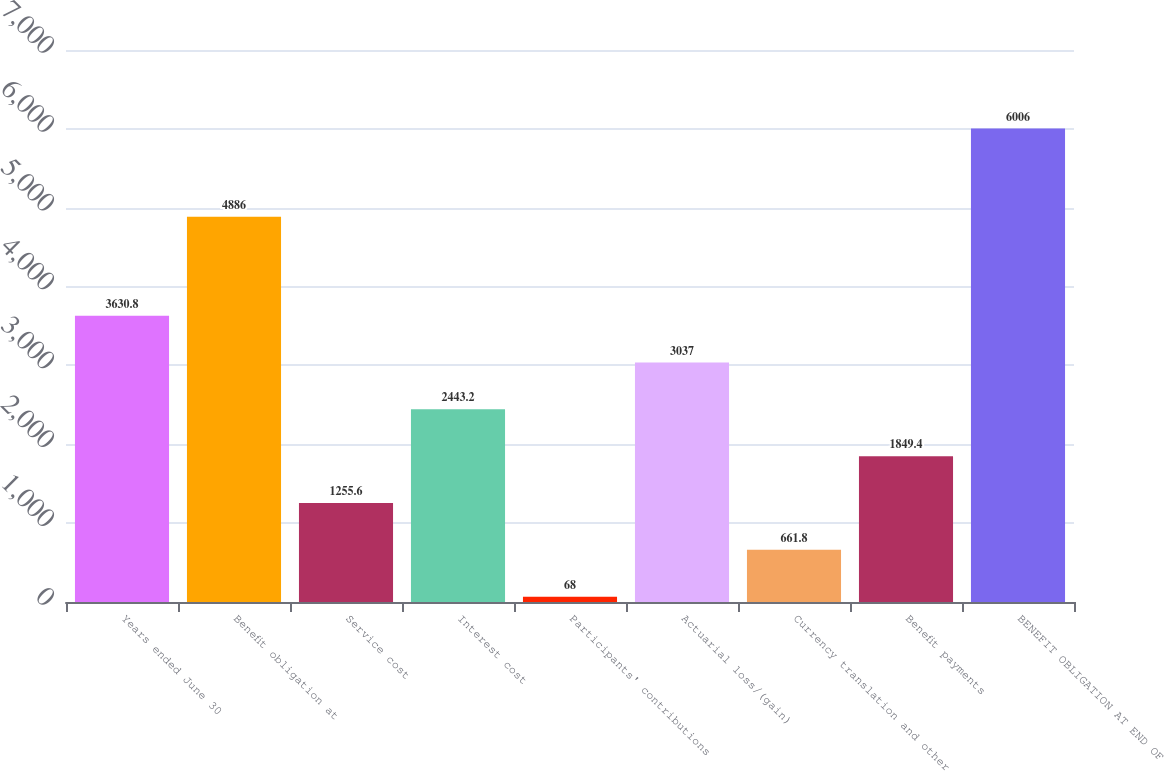<chart> <loc_0><loc_0><loc_500><loc_500><bar_chart><fcel>Years ended June 30<fcel>Benefit obligation at<fcel>Service cost<fcel>Interest cost<fcel>Participants' contributions<fcel>Actuarial loss/(gain)<fcel>Currency translation and other<fcel>Benefit payments<fcel>BENEFIT OBLIGATION AT END OF<nl><fcel>3630.8<fcel>4886<fcel>1255.6<fcel>2443.2<fcel>68<fcel>3037<fcel>661.8<fcel>1849.4<fcel>6006<nl></chart> 